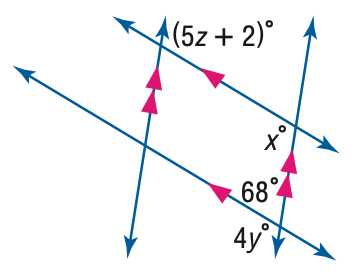Answer the mathemtical geometry problem and directly provide the correct option letter.
Question: Find y in the figure.
Choices: A: 22 B: 24 C: 26 D: 28 D 